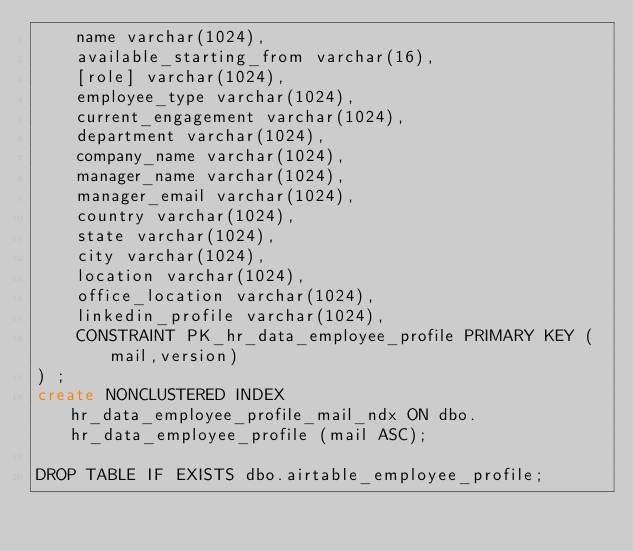<code> <loc_0><loc_0><loc_500><loc_500><_SQL_>    name varchar(1024),
    available_starting_from varchar(16),
    [role] varchar(1024),
    employee_type varchar(1024),
    current_engagement varchar(1024),
    department varchar(1024),
    company_name varchar(1024),
    manager_name varchar(1024),
    manager_email varchar(1024),
    country varchar(1024),
    state varchar(1024),
    city varchar(1024),
    location varchar(1024),
    office_location varchar(1024),
    linkedin_profile varchar(1024),
    CONSTRAINT PK_hr_data_employee_profile PRIMARY KEY (mail,version)
) ;
create NONCLUSTERED INDEX hr_data_employee_profile_mail_ndx ON dbo.hr_data_employee_profile (mail ASC);

DROP TABLE IF EXISTS dbo.airtable_employee_profile;
</code> 